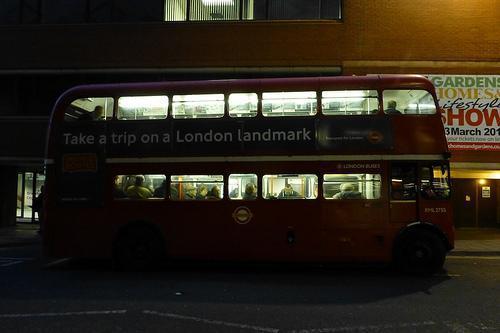How many buses are there?
Give a very brief answer. 1. How many levels is the bus?
Give a very brief answer. 2. 